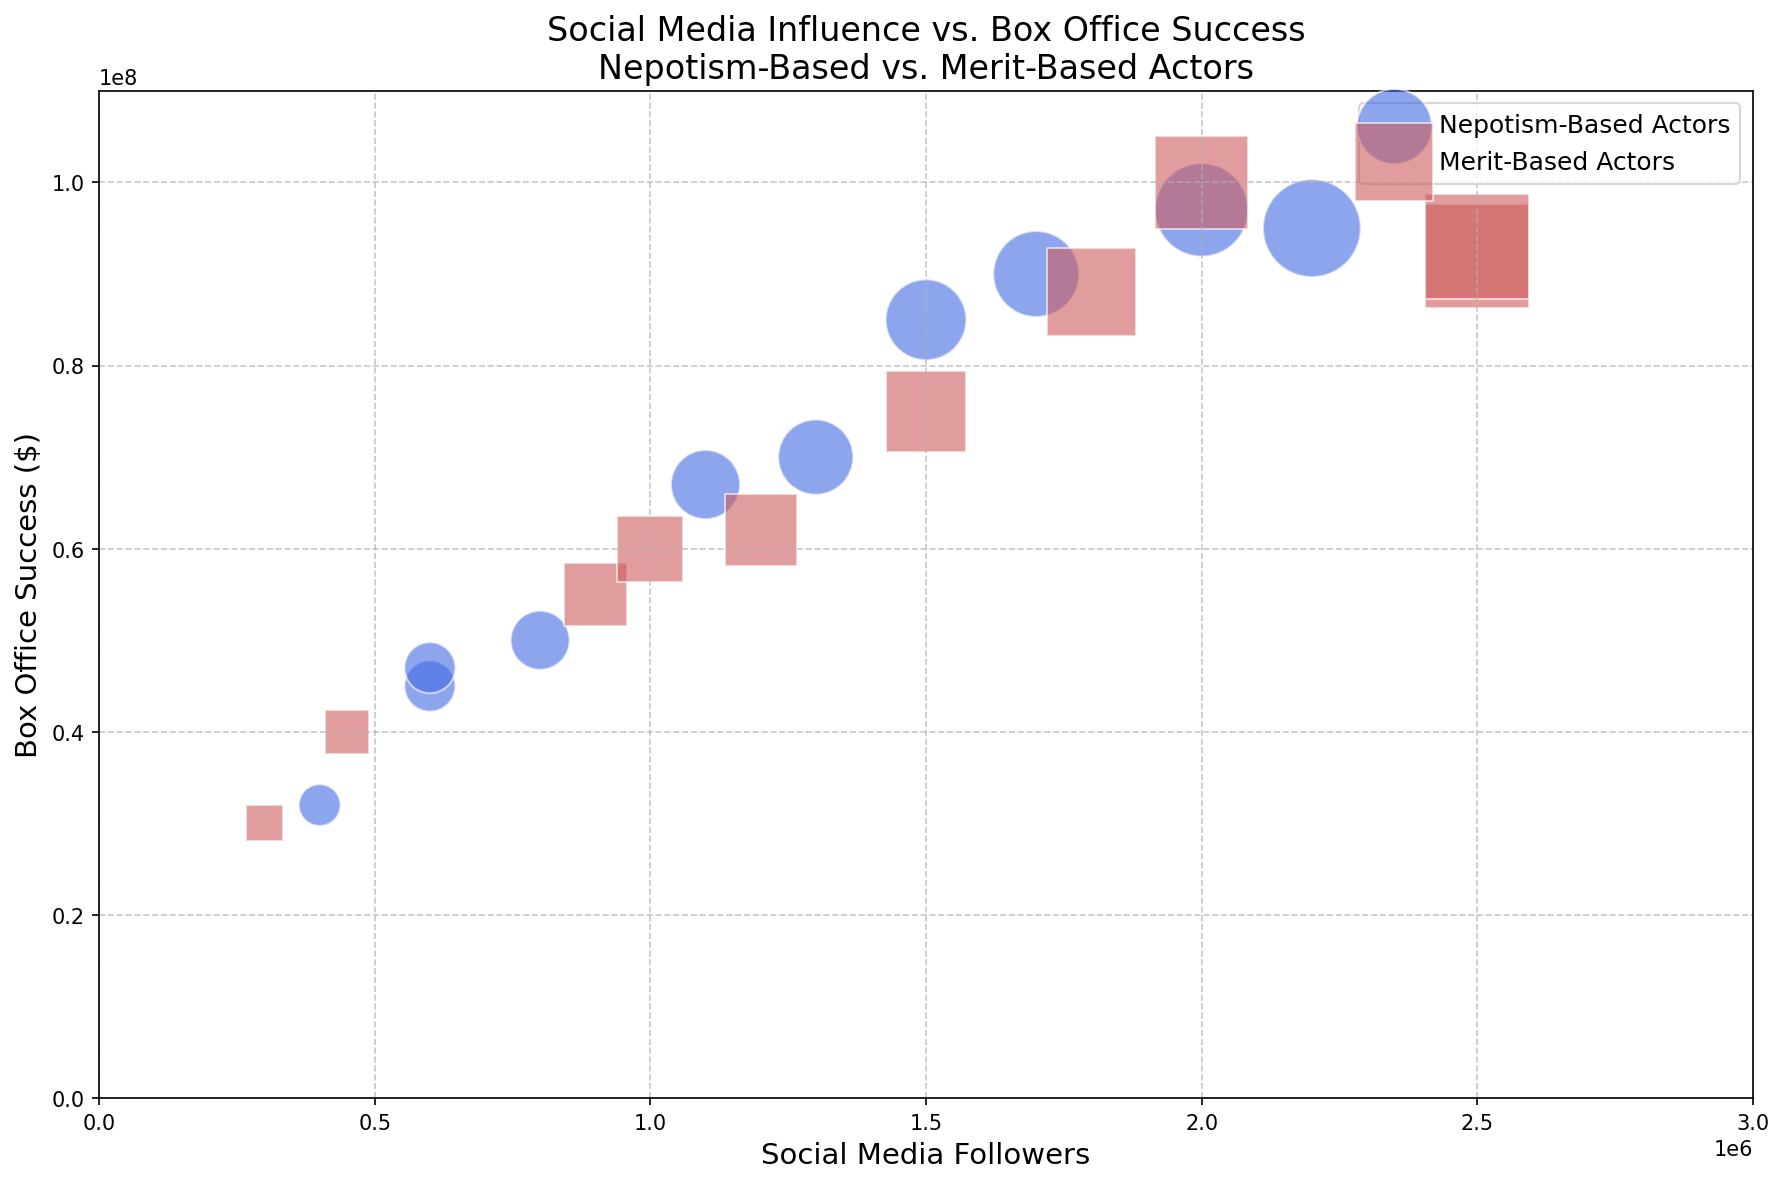What is the relationship between social media followers and box office success for nepotism-based actors compared to merit-based actors? First, observe that both nepotism-based and merit-based actors are represented by different colors and markers (blue circles and red squares respectively). Analyze if higher social media followers tend to correlate with higher box office success visibly for each group. Nepotism-based actors exhibit a slightly positive relationship, while merit-based actors display a broader and more dispersed pattern of success, suggesting a weaker correlation.
Answer: Nepotism-based: slightly positive correlation; Merit-based: weaker, more dispersed pattern Which type of actors has the highest box office success, nepotism-based or merit-based? Scan the vertical axis ("Box Office Success") for the highest values and identify the corresponding markers. The highest box office success is marked by a red square, indicating a merit-based actor.
Answer: Merit-based Among the actors with social media followers between 1,500,000 and 2,000,000, which group shows higher box office success on average? Identify the actors who fall within the social media follower range of 1,500,000 to 2,000,000 for both groups. Calculate the average box office success for each type: sum the box office success values and divide by the number of actors for both groups. Nepotism-based actors: Actor1, Actor5, Actor9, Actor13 (85M + 97M + 95M + 90M), average = 91.75M; Merit-based actors: Actor8, Actor16 (88M + 75M), average = 81.5M. Therefore, nepotism-based actors show higher average success.
Answer: Nepotism-based Compare the social media influence of the top box office grossing actor from each group. Identify the actor with the highest box office success in each category. For nepotism-based actors, the highest is 97M (Actor5 with 2,000,000 followers). For merit-based actors, the highest is 100M (Actor14 with 2,000,000 followers). Both actors have the same number of followers.
Answer: Equal How does the box office success variability compare between nepotism-based and merit-based actors? Observe the range and distribution of box office success values for both groups. Nepotism-based actors' box office success values range from approximately 30M to 97M, while merit-based actors range from approximately 30M to 100M. The wider spread in merit-based actors implies higher variability.
Answer: Merit-based: higher variability Find the smallest social media following for a nepotism-based actor who achieves a high box office success (greater than 70 million). Consider only the nepotism-based actors with box office success above 70 million and look for the one with the smallest social media following. Actor1 has 1,500,000 followers with 85 million success, Actor5 has 2,000,000 followers with 97 million success, Actor9 has 2,200,000 followers with 95 million success. The smallest followers in this range is 1,500,000 by Actor1.
Answer: 1,500,000 Which merit-based actor with moderate social media influence shows significant box office success? (Use a range of 1,000,000 to 2,000,000 followers for social media influence and box office success greater than 80 million) Filter the merit-based actors within the social media follower range of 1,000,000 to 2,000,000, then check their box office success levels. Only Actor8 and Actor14 fit this criterion, with Actor8 at 1,800,000 followers and 88 million success, Actor14 at 2,000,000 followers and 100 million success. Both have significant success within moderate social media influence ranges.
Answer: Actor8 and Actor14 